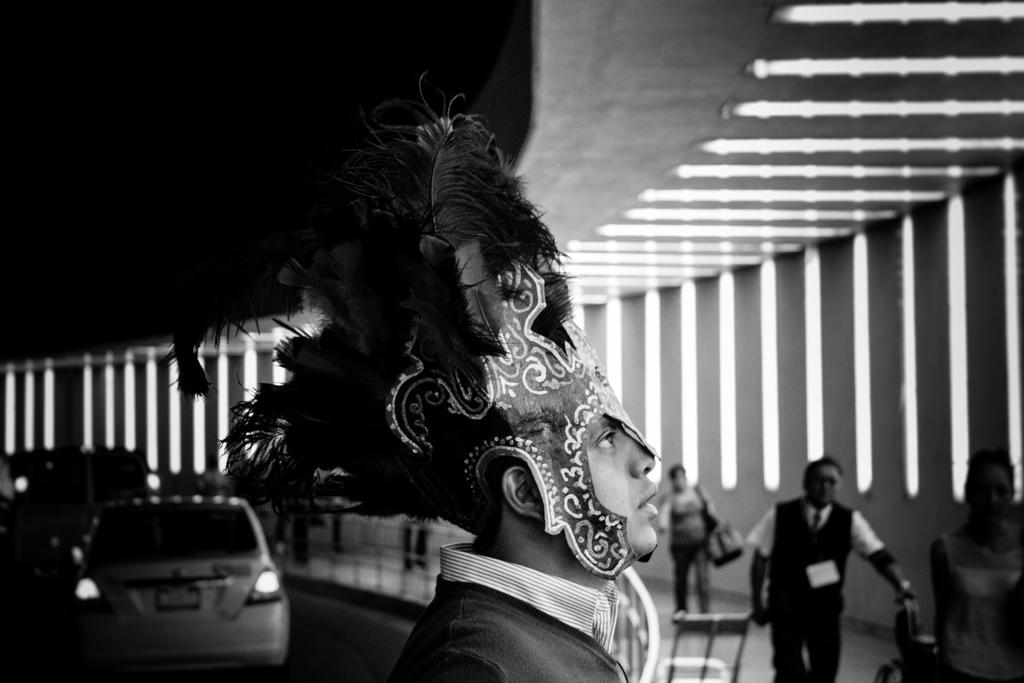What is the color scheme of the image? The image is black and white. Where are the people located in the image? The people are on the right side of the image. What can be seen on the left side of the image? There are vehicles on the left side of the image. Can you describe the appearance of a specific person in the image? Yes, there is a person wearing a fancy cap and a mask in the image. What type of glue is being used to hold the tent together in the image? There is no tent or glue present in the image. How does the drain affect the people and vehicles in the image? There is no drain present in the image. 